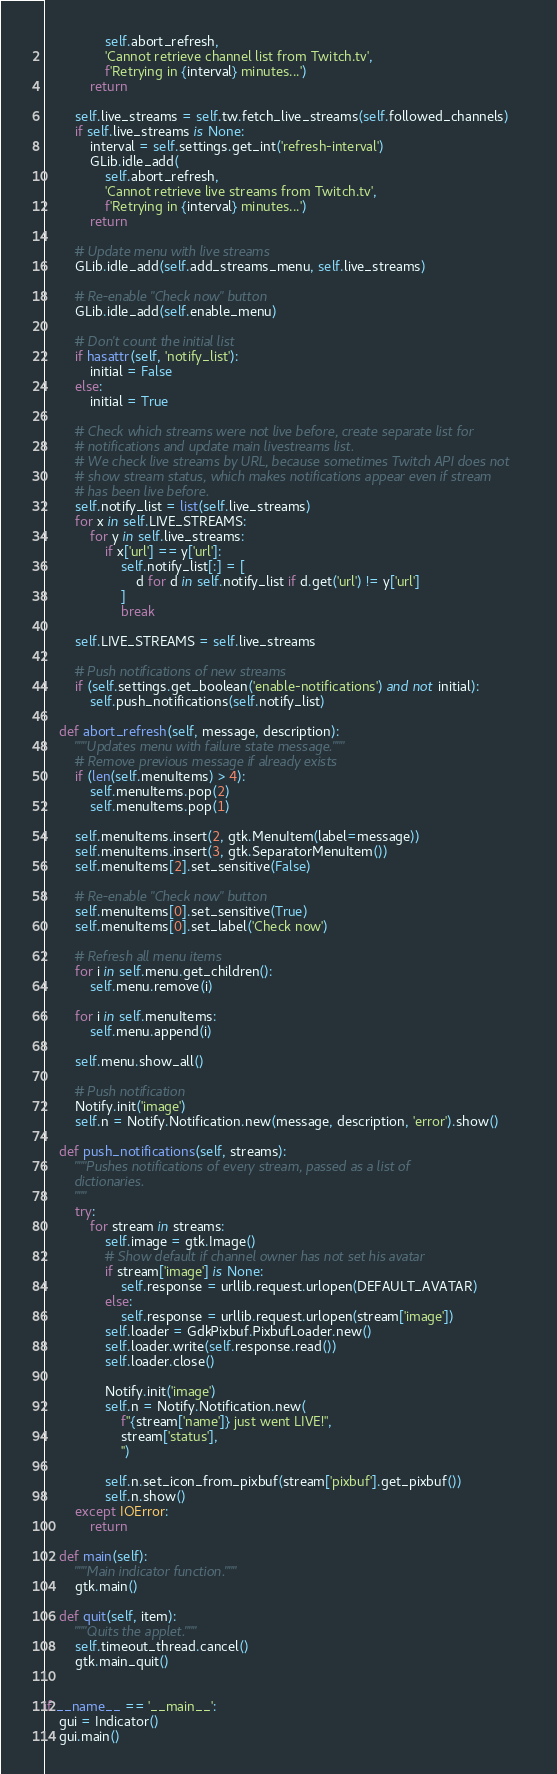Convert code to text. <code><loc_0><loc_0><loc_500><loc_500><_Python_>                self.abort_refresh,
                'Cannot retrieve channel list from Twitch.tv',
                f'Retrying in {interval} minutes...')
            return

        self.live_streams = self.tw.fetch_live_streams(self.followed_channels)
        if self.live_streams is None:
            interval = self.settings.get_int('refresh-interval')
            GLib.idle_add(
                self.abort_refresh,
                'Cannot retrieve live streams from Twitch.tv',
                f'Retrying in {interval} minutes...')
            return

        # Update menu with live streams
        GLib.idle_add(self.add_streams_menu, self.live_streams)

        # Re-enable "Check now" button
        GLib.idle_add(self.enable_menu)

        # Don't count the initial list
        if hasattr(self, 'notify_list'):
            initial = False
        else:
            initial = True

        # Check which streams were not live before, create separate list for
        # notifications and update main livestreams list.
        # We check live streams by URL, because sometimes Twitch API does not
        # show stream status, which makes notifications appear even if stream
        # has been live before.
        self.notify_list = list(self.live_streams)
        for x in self.LIVE_STREAMS:
            for y in self.live_streams:
                if x['url'] == y['url']:
                    self.notify_list[:] = [
                        d for d in self.notify_list if d.get('url') != y['url']
                    ]
                    break

        self.LIVE_STREAMS = self.live_streams

        # Push notifications of new streams
        if (self.settings.get_boolean('enable-notifications') and not initial):
            self.push_notifications(self.notify_list)

    def abort_refresh(self, message, description):
        """Updates menu with failure state message."""
        # Remove previous message if already exists
        if (len(self.menuItems) > 4):
            self.menuItems.pop(2)
            self.menuItems.pop(1)

        self.menuItems.insert(2, gtk.MenuItem(label=message))
        self.menuItems.insert(3, gtk.SeparatorMenuItem())
        self.menuItems[2].set_sensitive(False)

        # Re-enable "Check now" button
        self.menuItems[0].set_sensitive(True)
        self.menuItems[0].set_label('Check now')

        # Refresh all menu items
        for i in self.menu.get_children():
            self.menu.remove(i)

        for i in self.menuItems:
            self.menu.append(i)

        self.menu.show_all()

        # Push notification
        Notify.init('image')
        self.n = Notify.Notification.new(message, description, 'error').show()

    def push_notifications(self, streams):
        """Pushes notifications of every stream, passed as a list of
        dictionaries.
        """
        try:
            for stream in streams:
                self.image = gtk.Image()
                # Show default if channel owner has not set his avatar
                if stream['image'] is None:
                    self.response = urllib.request.urlopen(DEFAULT_AVATAR)
                else:
                    self.response = urllib.request.urlopen(stream['image'])
                self.loader = GdkPixbuf.PixbufLoader.new()
                self.loader.write(self.response.read())
                self.loader.close()

                Notify.init('image')
                self.n = Notify.Notification.new(
                    f"{stream['name']} just went LIVE!",
                    stream['status'],
                    '')

                self.n.set_icon_from_pixbuf(stream['pixbuf'].get_pixbuf())
                self.n.show()
        except IOError:
            return

    def main(self):
        """Main indicator function."""
        gtk.main()

    def quit(self, item):
        """Quits the applet."""
        self.timeout_thread.cancel()
        gtk.main_quit()


if __name__ == '__main__':
    gui = Indicator()
    gui.main()
</code> 